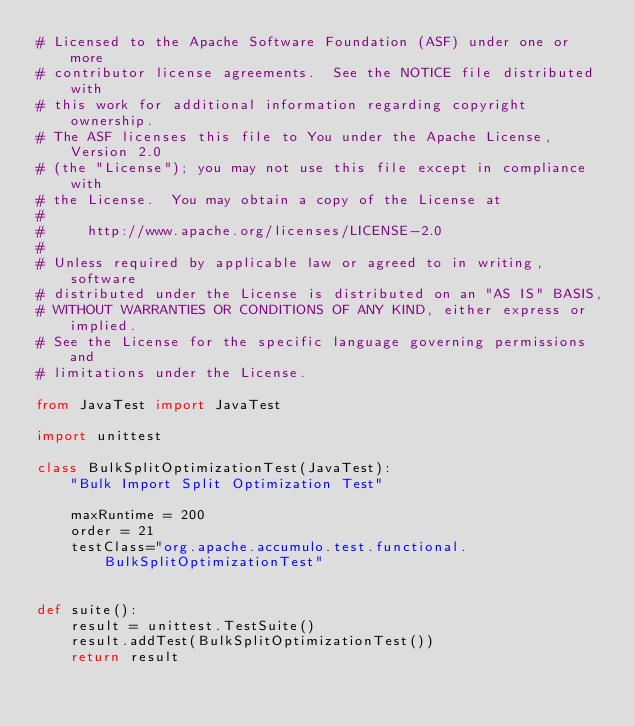<code> <loc_0><loc_0><loc_500><loc_500><_Python_># Licensed to the Apache Software Foundation (ASF) under one or more
# contributor license agreements.  See the NOTICE file distributed with
# this work for additional information regarding copyright ownership.
# The ASF licenses this file to You under the Apache License, Version 2.0
# (the "License"); you may not use this file except in compliance with
# the License.  You may obtain a copy of the License at
#
#     http://www.apache.org/licenses/LICENSE-2.0
#
# Unless required by applicable law or agreed to in writing, software
# distributed under the License is distributed on an "AS IS" BASIS,
# WITHOUT WARRANTIES OR CONDITIONS OF ANY KIND, either express or implied.
# See the License for the specific language governing permissions and
# limitations under the License.

from JavaTest import JavaTest

import unittest

class BulkSplitOptimizationTest(JavaTest):
    "Bulk Import Split Optimization Test"

    maxRuntime = 200
    order = 21
    testClass="org.apache.accumulo.test.functional.BulkSplitOptimizationTest"


def suite():
    result = unittest.TestSuite()
    result.addTest(BulkSplitOptimizationTest())
    return result
</code> 